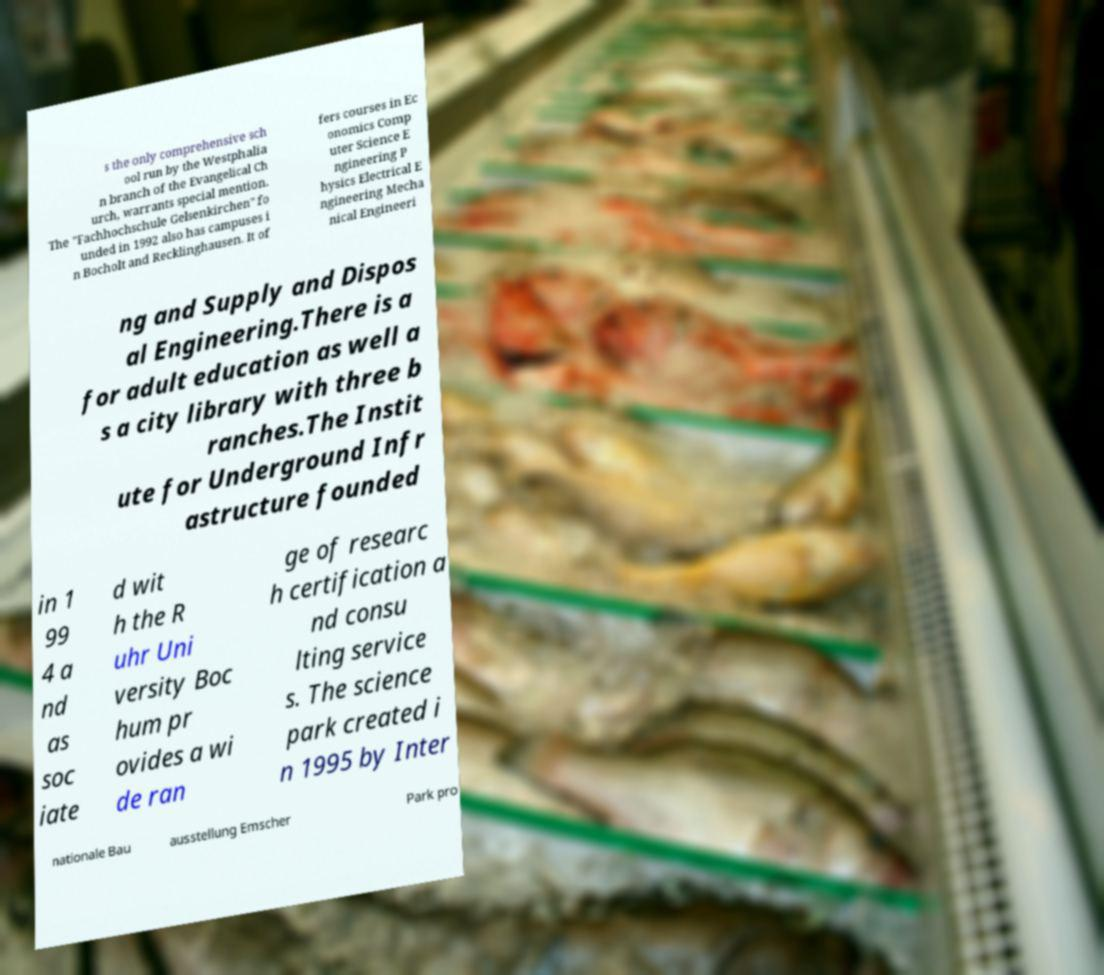What messages or text are displayed in this image? I need them in a readable, typed format. s the only comprehensive sch ool run by the Westphalia n branch of the Evangelical Ch urch, warrants special mention. The "Fachhochschule Gelsenkirchen" fo unded in 1992 also has campuses i n Bocholt and Recklinghausen. It of fers courses in Ec onomics Comp uter Science E ngineering P hysics Electrical E ngineering Mecha nical Engineeri ng and Supply and Dispos al Engineering.There is a for adult education as well a s a city library with three b ranches.The Instit ute for Underground Infr astructure founded in 1 99 4 a nd as soc iate d wit h the R uhr Uni versity Boc hum pr ovides a wi de ran ge of researc h certification a nd consu lting service s. The science park created i n 1995 by Inter nationale Bau ausstellung Emscher Park pro 